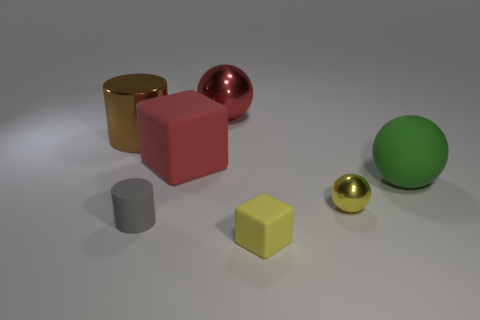Is the color of the block in front of the gray cylinder the same as the metallic ball in front of the brown cylinder?
Ensure brevity in your answer.  Yes. What is the color of the object that is on the right side of the gray matte thing and in front of the tiny ball?
Offer a terse response. Yellow. What number of other things are there of the same shape as the tiny metal thing?
Your answer should be very brief. 2. There is a block that is the same size as the brown metal thing; what is its color?
Provide a succinct answer. Red. What is the color of the large object on the right side of the yellow rubber thing?
Your response must be concise. Green. There is a large rubber object that is left of the red sphere; are there any small yellow rubber blocks in front of it?
Your answer should be compact. Yes. There is a gray object; is it the same shape as the big thing that is to the left of the large rubber block?
Ensure brevity in your answer.  Yes. How big is the rubber object that is left of the large rubber ball and behind the tiny shiny sphere?
Your answer should be very brief. Large. Is there a small gray block that has the same material as the small yellow sphere?
Your answer should be compact. No. There is a thing that is the same color as the tiny matte cube; what size is it?
Your response must be concise. Small. 